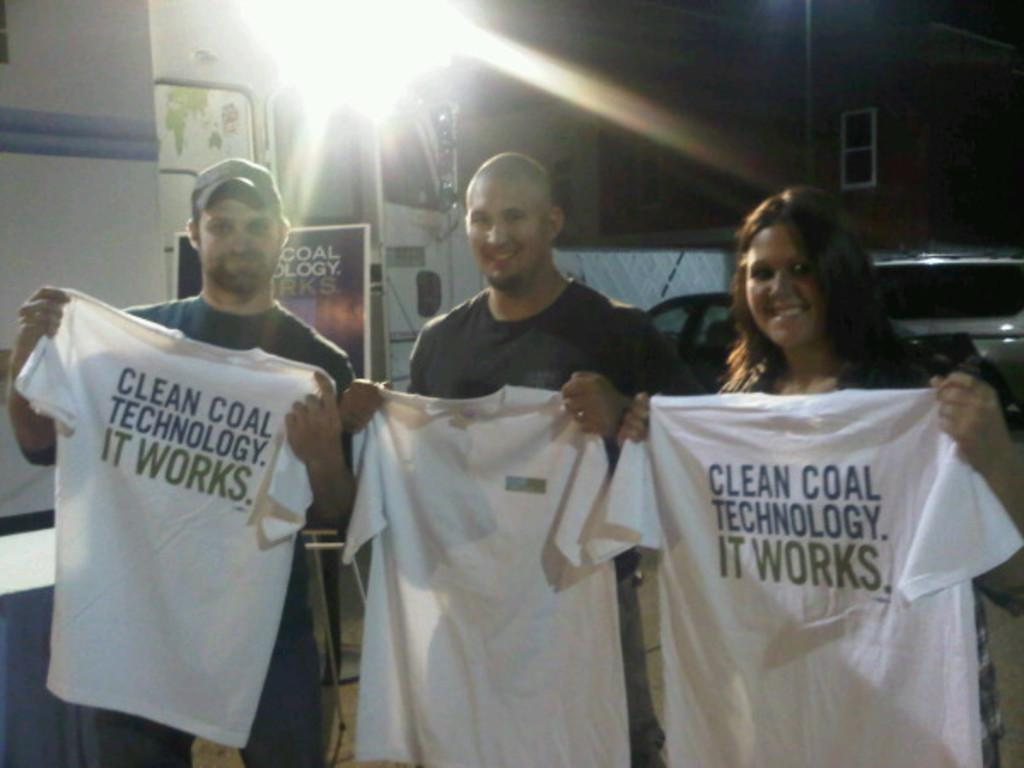How many people are in the image? There are three people in the image. What are the people holding in the image? The people are holding t-shirts. Can you describe the t-shirts? There is writing on at least two of the t-shirts. What can be seen in the background of the image? There is a light, a hoarding, a building, vehicles, and other unspecified things in the background of the image. What type of scarf is being twisted by one of the people in the image? There is no scarf present in the image, nor is anyone twisting anything. 